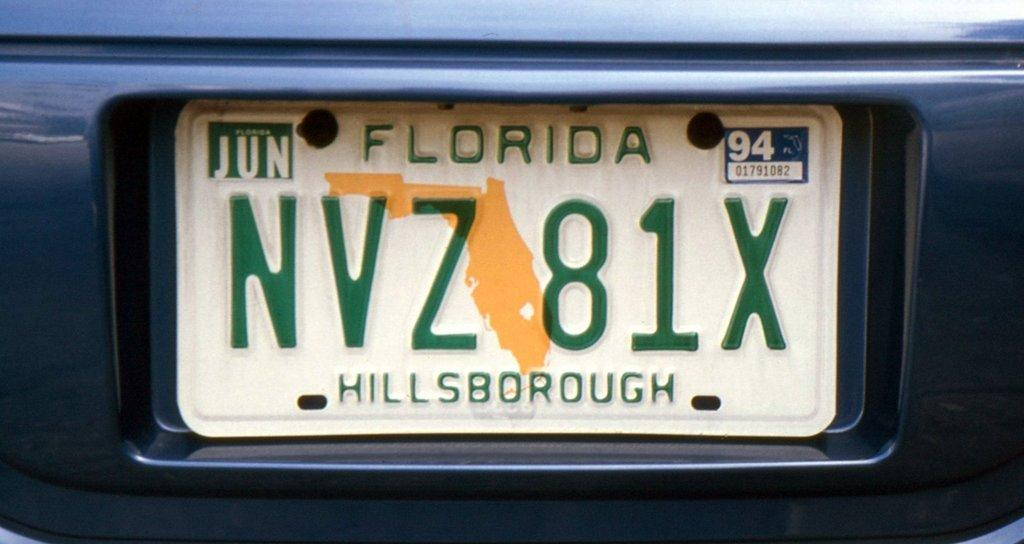Provide a one-sentence caption for the provided image. a green and white Florida license plate from hillsborough. 